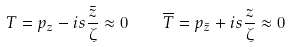<formula> <loc_0><loc_0><loc_500><loc_500>T = p _ { z } - i s \frac { \bar { z } } { \zeta } \approx 0 \quad \overline { T } = p _ { \bar { z } } + i s \frac { z } { \zeta } \approx 0</formula> 